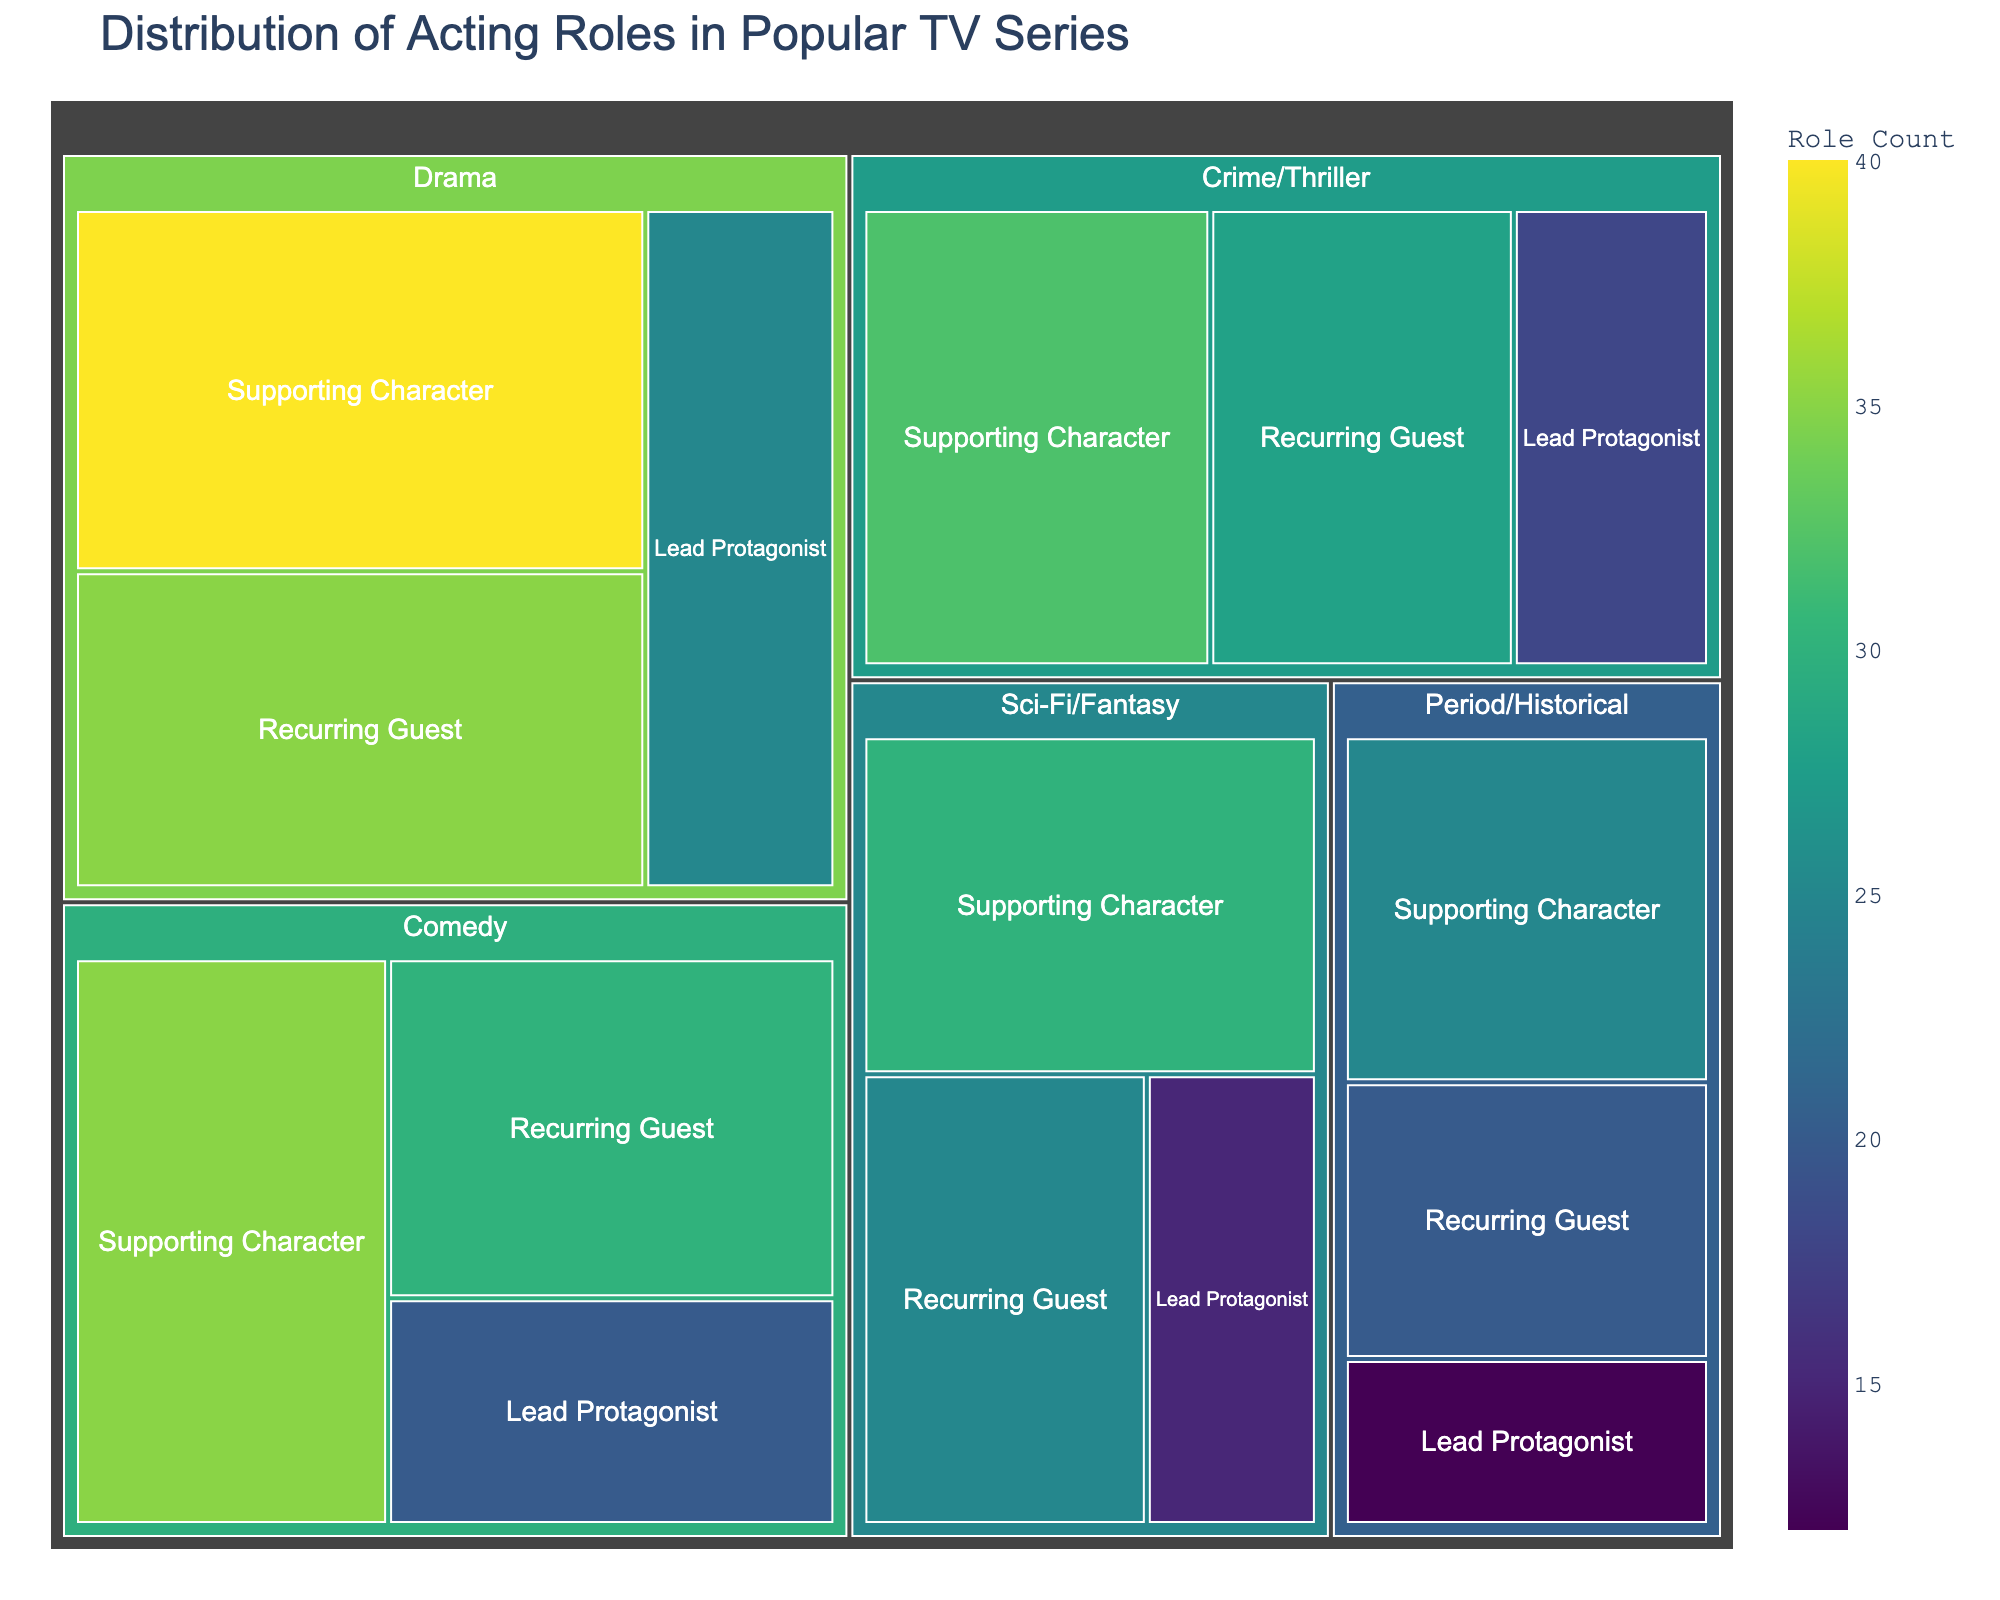How many total roles are there in the Drama genre? To find the total roles in the Drama genre, sum up the Role Count for all character types within that genre. That's 25 (Lead Protagonist) + 40 (Supporting Character) + 35 (Recurring Guest) = 100.
Answer: 100 Which genre has the highest number of roles? Look at the genres and compare their total role counts. Drama has 100, Comedy has 85, Sci-Fi/Fantasy has 70, Crime/Thriller has 78, and Period/Historical has 57. Drama has the highest number.
Answer: Drama Which character type is most frequent in the Comedy genre? Compare the Role Count values for character types within Comedy. Supporting Character has 35, Lead Protagonist has 20, and Recurring Guest has 30. Supporting Character is the most frequent.
Answer: Supporting Character What is the difference in Role Count between Recurring Guests in Sci-Fi/Fantasy and Crime/Thriller? Find the Role Count for Recurring Guests in both genres and subtract. Sci-Fi/Fantasy has 25, Crime/Thriller has 28. The difference is 28 - 25 = 3.
Answer: 3 What is the total Role Count for Supporting Characters across all genres? Sum the Role Count for Supporting Characters in all genres. That's 40 (Drama) + 35 (Comedy) + 30 (Sci-Fi/Fantasy) + 32 (Crime/Thriller) + 25 (Period/Historical) = 162.
Answer: 162 How does the Role Count for Lead Protagonists in Period/Historical compare to Drama? Compare the Role Counts for Lead Protagonists in these two genres. Period/Historical has 12, while Drama has 25. Drama has more.
Answer: Drama Which genre has the lowest number of Lead Protagonist roles? Compare the Role Counts for Lead Protagonists in each genre. Period/Historical has 12, which is the lowest among them.
Answer: Period/Historical What is the average Role Count for Recurring Guests in all genres? Sum the Role Counts for Recurring Guests across all genres and divide by the number of genres (5). (35 + 30 + 25 + 28 + 20) / 5 = 27.6.
Answer: 27.6 Is the number of Supporting Characters in Drama greater than the total number of Lead Protagonists in Comedy and Crime/Thriller combined? Drama has 40 Supporting Characters. Total Lead Protagonists in Comedy (20) and Crime/Thriller (18) combined is 38. 40 > 38.
Answer: Yes 